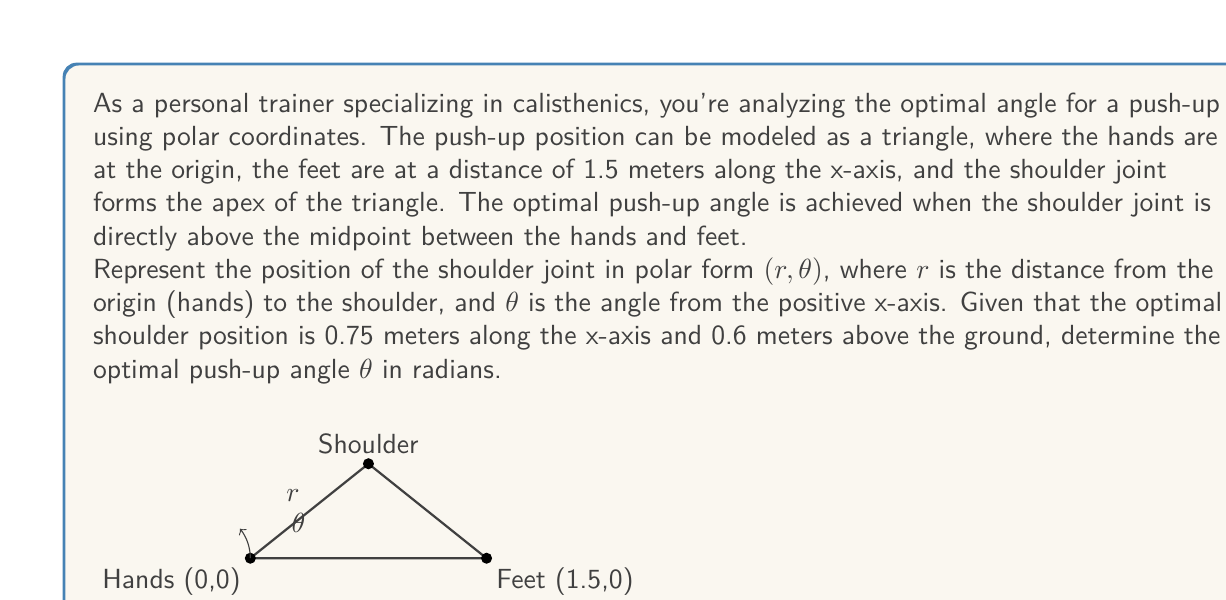Teach me how to tackle this problem. Let's approach this step-by-step:

1) We're given the Cartesian coordinates of the shoulder joint: (0.75, 0.6)

2) To convert from Cartesian $(x, y)$ to polar $(r, \theta)$ coordinates, we use these formulas:

   $r = \sqrt{x^2 + y^2}$
   $\theta = \arctan(\frac{y}{x})$

3) Let's calculate $r$ first:
   
   $r = \sqrt{0.75^2 + 0.6^2} = \sqrt{0.5625 + 0.36} = \sqrt{0.9225} \approx 0.9605$ meters

4) Now, let's calculate $\theta$:
   
   $\theta = \arctan(\frac{0.6}{0.75}) = \arctan(0.8)$

5) Using a calculator or mathematical software, we can evaluate this:
   
   $\theta \approx 0.6747$ radians

This angle $\theta$ represents the optimal push-up angle in radians.
Answer: $\theta \approx 0.6747$ radians 